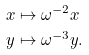<formula> <loc_0><loc_0><loc_500><loc_500>x & \mapsto \omega ^ { - 2 } x \\ y & \mapsto \omega ^ { - 3 } y .</formula> 